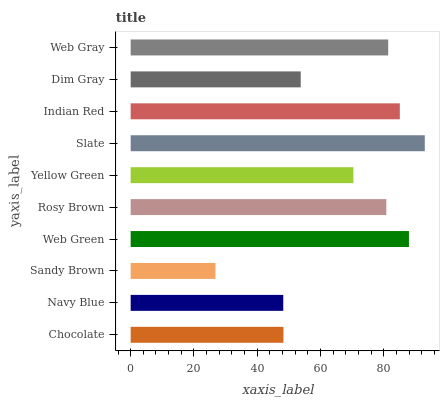Is Sandy Brown the minimum?
Answer yes or no. Yes. Is Slate the maximum?
Answer yes or no. Yes. Is Navy Blue the minimum?
Answer yes or no. No. Is Navy Blue the maximum?
Answer yes or no. No. Is Chocolate greater than Navy Blue?
Answer yes or no. Yes. Is Navy Blue less than Chocolate?
Answer yes or no. Yes. Is Navy Blue greater than Chocolate?
Answer yes or no. No. Is Chocolate less than Navy Blue?
Answer yes or no. No. Is Rosy Brown the high median?
Answer yes or no. Yes. Is Yellow Green the low median?
Answer yes or no. Yes. Is Yellow Green the high median?
Answer yes or no. No. Is Dim Gray the low median?
Answer yes or no. No. 